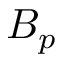<formula> <loc_0><loc_0><loc_500><loc_500>B _ { p }</formula> 